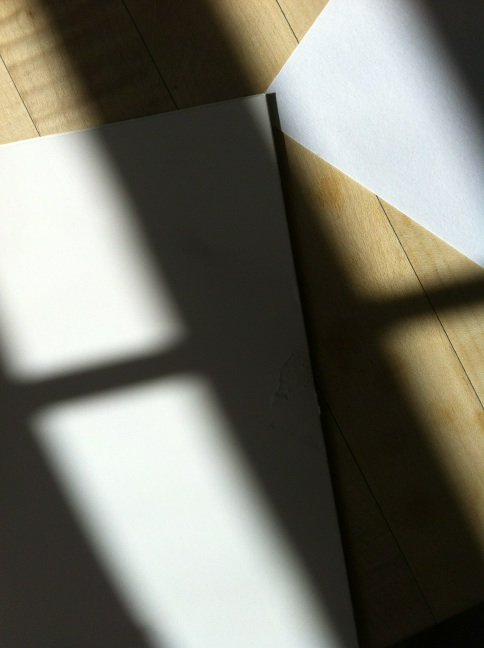How might the angle of lighting affect the perception of the jacket’s color? The angle of the lighting in the image causes the jacket's color to appear more intense and saturated within the shadowed areas, while lighter areas may look faded. This effect can give the material a dynamic appearance, changing depending on the light's direction and intensity. 